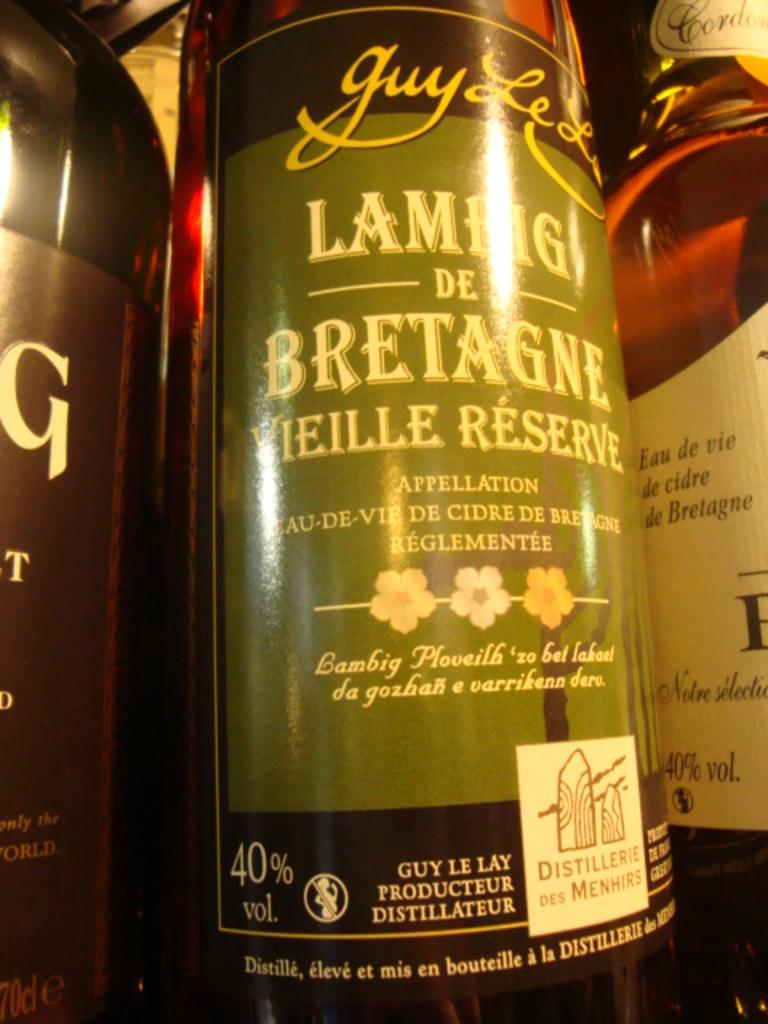<image>
Give a short and clear explanation of the subsequent image. A bottle of Lambig de Bretagne is next to several other bottles. 